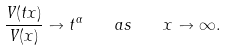Convert formula to latex. <formula><loc_0><loc_0><loc_500><loc_500>\frac { V ( t x ) } { V ( x ) } \to t ^ { \alpha } \quad a s \quad x \to \infty .</formula> 